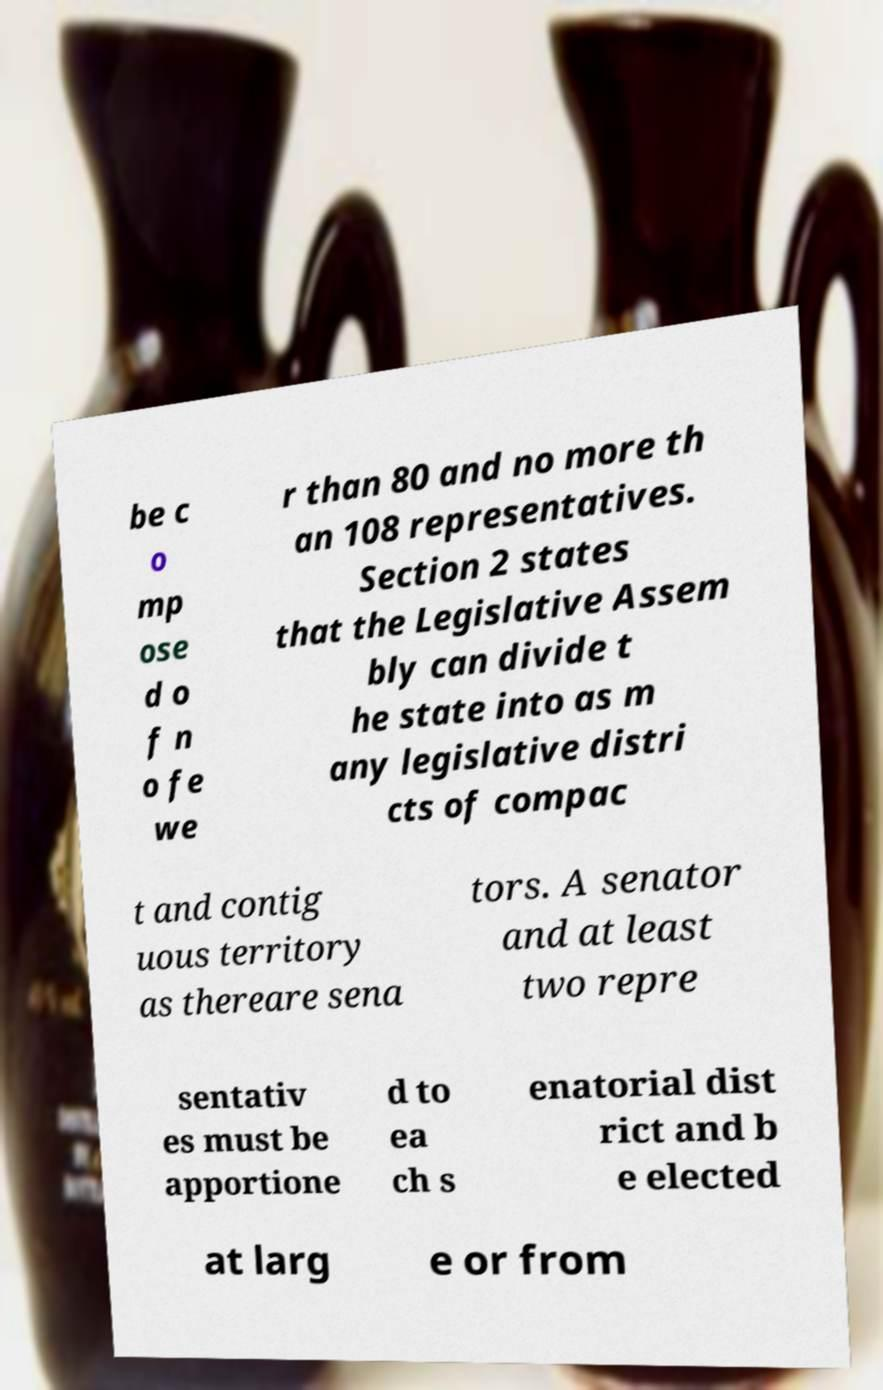I need the written content from this picture converted into text. Can you do that? be c o mp ose d o f n o fe we r than 80 and no more th an 108 representatives. Section 2 states that the Legislative Assem bly can divide t he state into as m any legislative distri cts of compac t and contig uous territory as thereare sena tors. A senator and at least two repre sentativ es must be apportione d to ea ch s enatorial dist rict and b e elected at larg e or from 